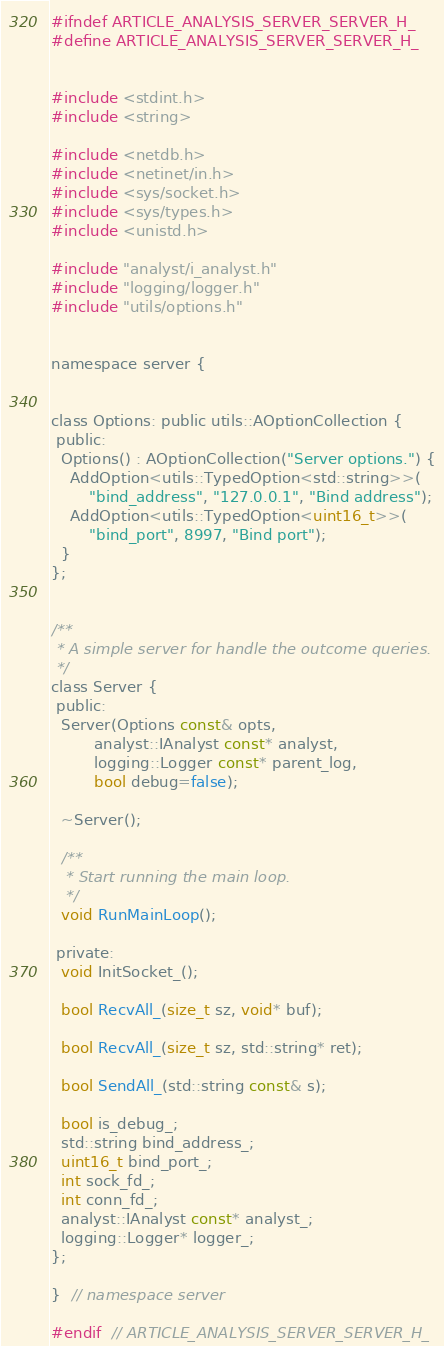<code> <loc_0><loc_0><loc_500><loc_500><_C_>#ifndef ARTICLE_ANALYSIS_SERVER_SERVER_H_
#define ARTICLE_ANALYSIS_SERVER_SERVER_H_


#include <stdint.h>
#include <string>

#include <netdb.h>
#include <netinet/in.h>
#include <sys/socket.h>
#include <sys/types.h>
#include <unistd.h>

#include "analyst/i_analyst.h"
#include "logging/logger.h"
#include "utils/options.h"


namespace server {


class Options: public utils::AOptionCollection {
 public:
  Options() : AOptionCollection("Server options.") {
    AddOption<utils::TypedOption<std::string>>(
        "bind_address", "127.0.0.1", "Bind address");
    AddOption<utils::TypedOption<uint16_t>>(
        "bind_port", 8997, "Bind port");
  }
};


/**
 * A simple server for handle the outcome queries.
 */
class Server {
 public:
  Server(Options const& opts,
         analyst::IAnalyst const* analyst,
         logging::Logger const* parent_log,
         bool debug=false);

  ~Server();

  /**
   * Start running the main loop.
   */
  void RunMainLoop();

 private:
  void InitSocket_();

  bool RecvAll_(size_t sz, void* buf);

  bool RecvAll_(size_t sz, std::string* ret);
  
  bool SendAll_(std::string const& s);

  bool is_debug_;
  std::string bind_address_;
  uint16_t bind_port_;
  int sock_fd_;
  int conn_fd_;
  analyst::IAnalyst const* analyst_;
  logging::Logger* logger_;
};

}  // namespace server

#endif  // ARTICLE_ANALYSIS_SERVER_SERVER_H_
</code> 